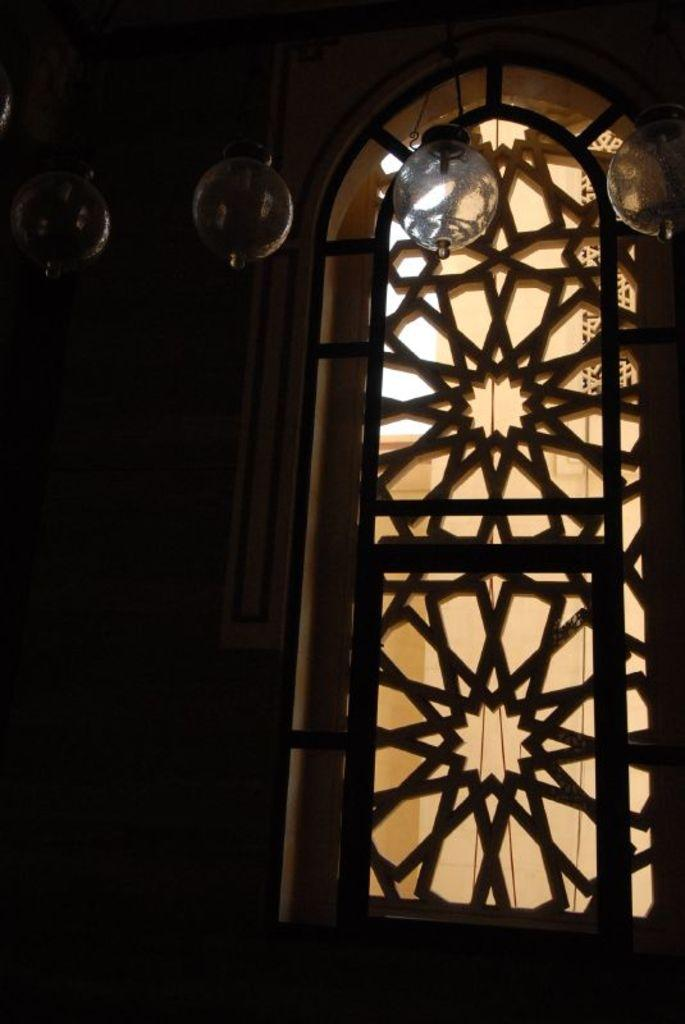What is a prominent feature in the image? There is a window with a design in the image. What objects are hanging at the top of the image? Glass lanterns are hanging at the top of the image. What type of bag is hanging next to the window in the image? There is no bag present in the image; it only features a window with a design and glass lanterns hanging at the top. What color is the flag flying outside the window in the image? There is no flag present in the image; it only features a window with a design and glass lanterns hanging at the top. 